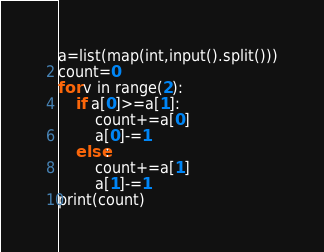Convert code to text. <code><loc_0><loc_0><loc_500><loc_500><_Python_>a=list(map(int,input().split()))
count=0
for v in range(2):
    if a[0]>=a[1]:
        count+=a[0]
        a[0]-=1
    else:
        count+=a[1]
        a[1]-=1
print(count)</code> 